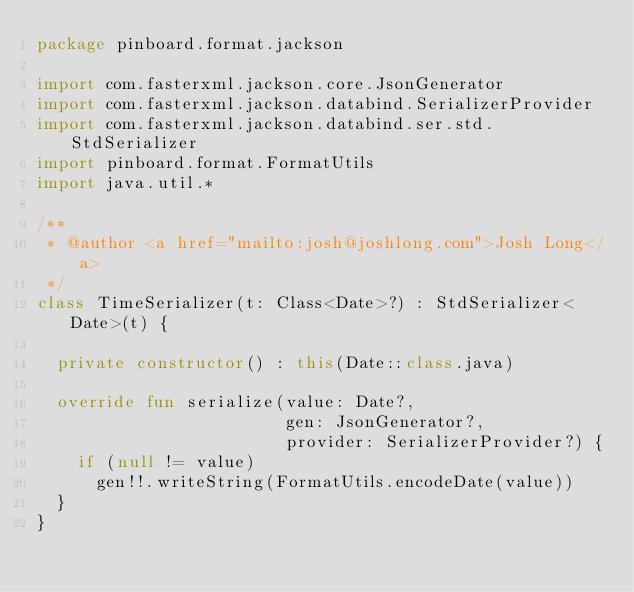Convert code to text. <code><loc_0><loc_0><loc_500><loc_500><_Kotlin_>package pinboard.format.jackson

import com.fasterxml.jackson.core.JsonGenerator
import com.fasterxml.jackson.databind.SerializerProvider
import com.fasterxml.jackson.databind.ser.std.StdSerializer
import pinboard.format.FormatUtils
import java.util.*

/**
 * @author <a href="mailto:josh@joshlong.com">Josh Long</a>
 */
class TimeSerializer(t: Class<Date>?) : StdSerializer<Date>(t) {

	private constructor() : this(Date::class.java)

	override fun serialize(value: Date?,
	                       gen: JsonGenerator?,
	                       provider: SerializerProvider?) {
		if (null != value)
			gen!!.writeString(FormatUtils.encodeDate(value))
	}
}</code> 